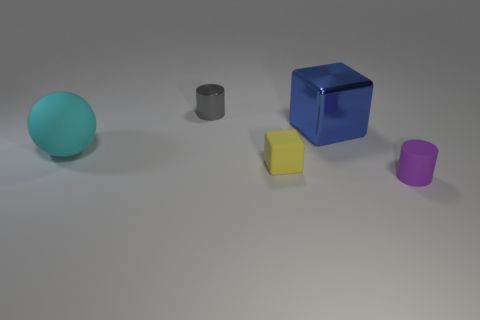Add 1 tiny cyan cylinders. How many objects exist? 6 Subtract all cyan blocks. Subtract all cyan spheres. How many blocks are left? 2 Subtract all cyan spheres. How many gray cylinders are left? 1 Subtract all big blue metal cubes. Subtract all small cylinders. How many objects are left? 2 Add 3 metallic things. How many metallic things are left? 5 Add 1 yellow cubes. How many yellow cubes exist? 2 Subtract all yellow cubes. How many cubes are left? 1 Subtract 0 cyan cubes. How many objects are left? 5 Subtract all cylinders. How many objects are left? 3 Subtract 2 cubes. How many cubes are left? 0 